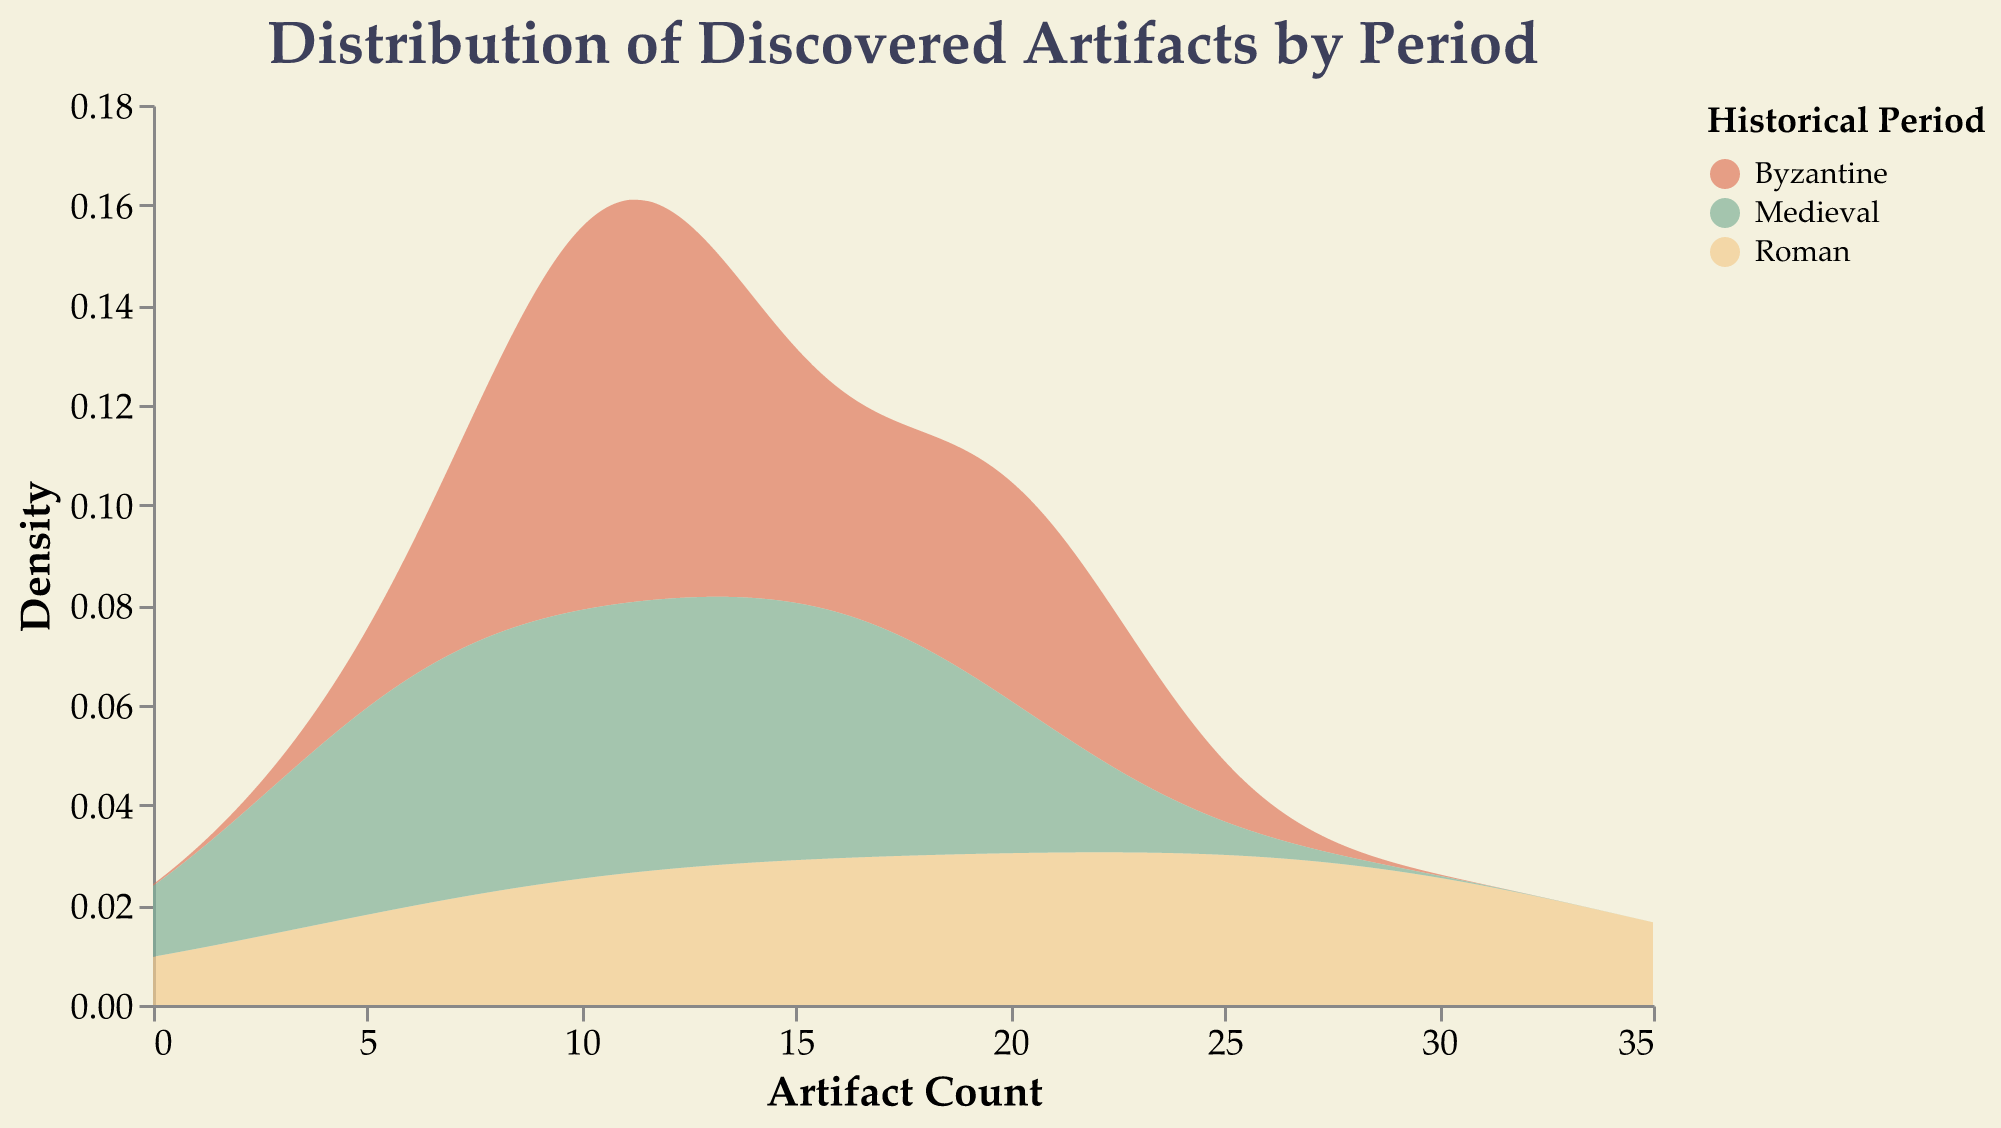what is the title of the figure? The title is usually located at the top of the figure and describes the main topic of the plot.
Answer: Distribution of Discovered Artifacts by Period Which period has the highest density peak? By looking at the height of the density peaks associated with each period, we can determine which one is the highest. The highest peak is in the Roman period indicated by the tallest area.
Answer: Roman What is the artifact count range displayed on the x-axis? The x-axis displays the range of artifact counts, which is mentioned in the title of the x-axis.
Answer: 0 to 35 Which period shows the widest spread of artifact densities? By comparing the horizontal extent of the density plots for each period, the period with the greatest width or spread is identified. The Roman period has the widest spread, with density stretching broadly across the x-axis.
Answer: Roman How does the density of Byzantine artifacts compare to Medieval artifacts at an artifact count of 20? By examining the densities of the Byzantine and Medieval periods at the specific count of 20 on the x-axis, we can compare the heights of the density areas. The Byzantine period shows a higher density than the Medieval period at this count.
Answer: Byzantine What is the most frequently discovered artifact type during the Roman period? The count for each artifact type within the Roman period can be compared to determine the most frequent one. The artifact with the highest count is Pottery, with a count of 30.
Answer: Pottery Which artifact count has the lowest density across all periods? Identifying the point on the x-axis with the lowest height in the density plots for all periods simultaneously helps find the count with the lowest density. The artifact count around 2-3 has the lowest density.
Answer: Around 2-3 Between Roman and Byzantine periods, which one shows a higher density for artifacts found in the range of 10-20? Evaluating the density curves within the specified artifact count range (10-20) and comparing the heights of the density plots for both Roman and Byzantine periods provides the answer. The Byzantine period has higher densities in this range.
Answer: Byzantine What is the relative density of artifacts found in the Medieval period at counts greater than 30, compared to other periods? Observing the density areas at counts greater than 30 on the x-axis across the different periods reveals that the Medieval period has relatively very low or almost negligible densities compared to other periods in this range.
Answer: Very low 